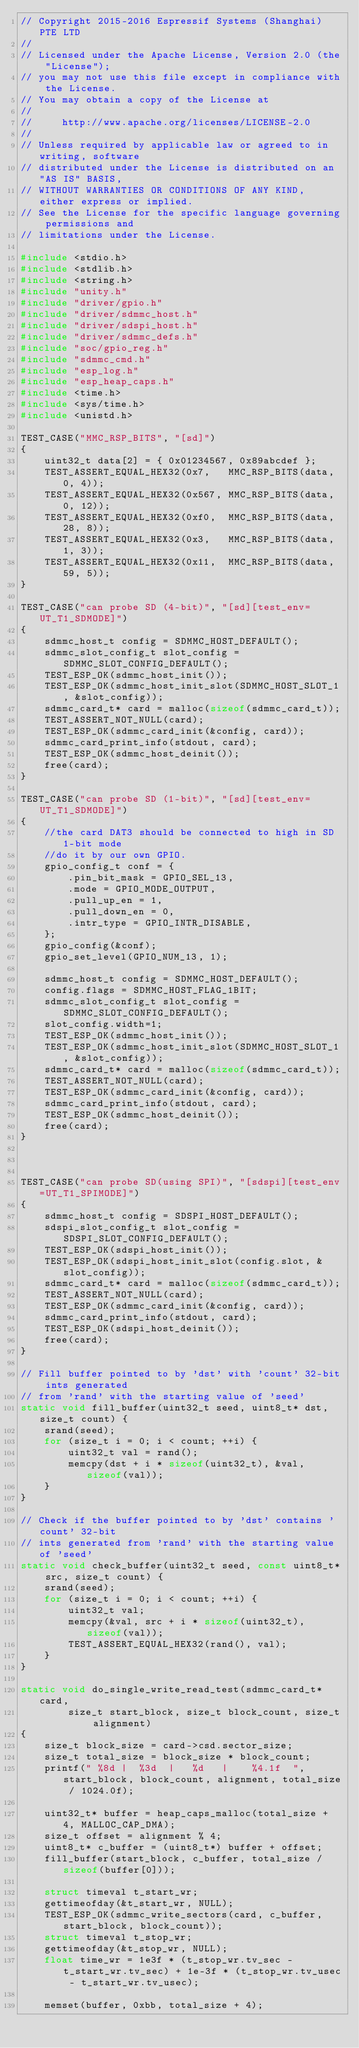<code> <loc_0><loc_0><loc_500><loc_500><_C_>// Copyright 2015-2016 Espressif Systems (Shanghai) PTE LTD
//
// Licensed under the Apache License, Version 2.0 (the "License");
// you may not use this file except in compliance with the License.
// You may obtain a copy of the License at
//
//     http://www.apache.org/licenses/LICENSE-2.0
//
// Unless required by applicable law or agreed to in writing, software
// distributed under the License is distributed on an "AS IS" BASIS,
// WITHOUT WARRANTIES OR CONDITIONS OF ANY KIND, either express or implied.
// See the License for the specific language governing permissions and
// limitations under the License.

#include <stdio.h>
#include <stdlib.h>
#include <string.h>
#include "unity.h"
#include "driver/gpio.h"
#include "driver/sdmmc_host.h"
#include "driver/sdspi_host.h"
#include "driver/sdmmc_defs.h"
#include "soc/gpio_reg.h"
#include "sdmmc_cmd.h"
#include "esp_log.h"
#include "esp_heap_caps.h"
#include <time.h>
#include <sys/time.h>
#include <unistd.h>

TEST_CASE("MMC_RSP_BITS", "[sd]")
{
    uint32_t data[2] = { 0x01234567, 0x89abcdef };
    TEST_ASSERT_EQUAL_HEX32(0x7,   MMC_RSP_BITS(data, 0, 4));
    TEST_ASSERT_EQUAL_HEX32(0x567, MMC_RSP_BITS(data, 0, 12));
    TEST_ASSERT_EQUAL_HEX32(0xf0,  MMC_RSP_BITS(data, 28, 8));
    TEST_ASSERT_EQUAL_HEX32(0x3,   MMC_RSP_BITS(data, 1, 3));
    TEST_ASSERT_EQUAL_HEX32(0x11,  MMC_RSP_BITS(data, 59, 5));
}

TEST_CASE("can probe SD (4-bit)", "[sd][test_env=UT_T1_SDMODE]")
{
    sdmmc_host_t config = SDMMC_HOST_DEFAULT();
    sdmmc_slot_config_t slot_config = SDMMC_SLOT_CONFIG_DEFAULT();
    TEST_ESP_OK(sdmmc_host_init());
    TEST_ESP_OK(sdmmc_host_init_slot(SDMMC_HOST_SLOT_1, &slot_config));
    sdmmc_card_t* card = malloc(sizeof(sdmmc_card_t));
    TEST_ASSERT_NOT_NULL(card);
    TEST_ESP_OK(sdmmc_card_init(&config, card));
    sdmmc_card_print_info(stdout, card);
    TEST_ESP_OK(sdmmc_host_deinit());
    free(card);
}

TEST_CASE("can probe SD (1-bit)", "[sd][test_env=UT_T1_SDMODE]")
{
    //the card DAT3 should be connected to high in SD 1-bit mode
    //do it by our own GPIO.
    gpio_config_t conf = {
        .pin_bit_mask = GPIO_SEL_13,
        .mode = GPIO_MODE_OUTPUT,
        .pull_up_en = 1,
        .pull_down_en = 0,
        .intr_type = GPIO_INTR_DISABLE,
    };
    gpio_config(&conf);
    gpio_set_level(GPIO_NUM_13, 1);

    sdmmc_host_t config = SDMMC_HOST_DEFAULT();
    config.flags = SDMMC_HOST_FLAG_1BIT;
    sdmmc_slot_config_t slot_config = SDMMC_SLOT_CONFIG_DEFAULT();
    slot_config.width=1;
    TEST_ESP_OK(sdmmc_host_init());
    TEST_ESP_OK(sdmmc_host_init_slot(SDMMC_HOST_SLOT_1, &slot_config));
    sdmmc_card_t* card = malloc(sizeof(sdmmc_card_t));
    TEST_ASSERT_NOT_NULL(card);
    TEST_ESP_OK(sdmmc_card_init(&config, card));
    sdmmc_card_print_info(stdout, card);
    TEST_ESP_OK(sdmmc_host_deinit());
    free(card);
}



TEST_CASE("can probe SD(using SPI)", "[sdspi][test_env=UT_T1_SPIMODE]")
{
    sdmmc_host_t config = SDSPI_HOST_DEFAULT();
    sdspi_slot_config_t slot_config = SDSPI_SLOT_CONFIG_DEFAULT();
    TEST_ESP_OK(sdspi_host_init());
    TEST_ESP_OK(sdspi_host_init_slot(config.slot, &slot_config));
    sdmmc_card_t* card = malloc(sizeof(sdmmc_card_t));
    TEST_ASSERT_NOT_NULL(card);
    TEST_ESP_OK(sdmmc_card_init(&config, card));
    sdmmc_card_print_info(stdout, card);
    TEST_ESP_OK(sdspi_host_deinit());
    free(card);
}

// Fill buffer pointed to by 'dst' with 'count' 32-bit ints generated
// from 'rand' with the starting value of 'seed'
static void fill_buffer(uint32_t seed, uint8_t* dst, size_t count) {
    srand(seed);
    for (size_t i = 0; i < count; ++i) {
        uint32_t val = rand();
        memcpy(dst + i * sizeof(uint32_t), &val, sizeof(val));
    }
}

// Check if the buffer pointed to by 'dst' contains 'count' 32-bit
// ints generated from 'rand' with the starting value of 'seed'
static void check_buffer(uint32_t seed, const uint8_t* src, size_t count) {
    srand(seed);
    for (size_t i = 0; i < count; ++i) {
        uint32_t val;
        memcpy(&val, src + i * sizeof(uint32_t), sizeof(val));
        TEST_ASSERT_EQUAL_HEX32(rand(), val);
    }
}

static void do_single_write_read_test(sdmmc_card_t* card,
        size_t start_block, size_t block_count, size_t alignment)
{
    size_t block_size = card->csd.sector_size;
    size_t total_size = block_size * block_count;
    printf(" %8d |  %3d  |   %d   |    %4.1f  ", start_block, block_count, alignment, total_size / 1024.0f);

    uint32_t* buffer = heap_caps_malloc(total_size + 4, MALLOC_CAP_DMA);
    size_t offset = alignment % 4;
    uint8_t* c_buffer = (uint8_t*) buffer + offset;
    fill_buffer(start_block, c_buffer, total_size / sizeof(buffer[0]));

    struct timeval t_start_wr;
    gettimeofday(&t_start_wr, NULL);
    TEST_ESP_OK(sdmmc_write_sectors(card, c_buffer, start_block, block_count));
    struct timeval t_stop_wr;
    gettimeofday(&t_stop_wr, NULL);
    float time_wr = 1e3f * (t_stop_wr.tv_sec - t_start_wr.tv_sec) + 1e-3f * (t_stop_wr.tv_usec - t_start_wr.tv_usec);

    memset(buffer, 0xbb, total_size + 4);
</code> 